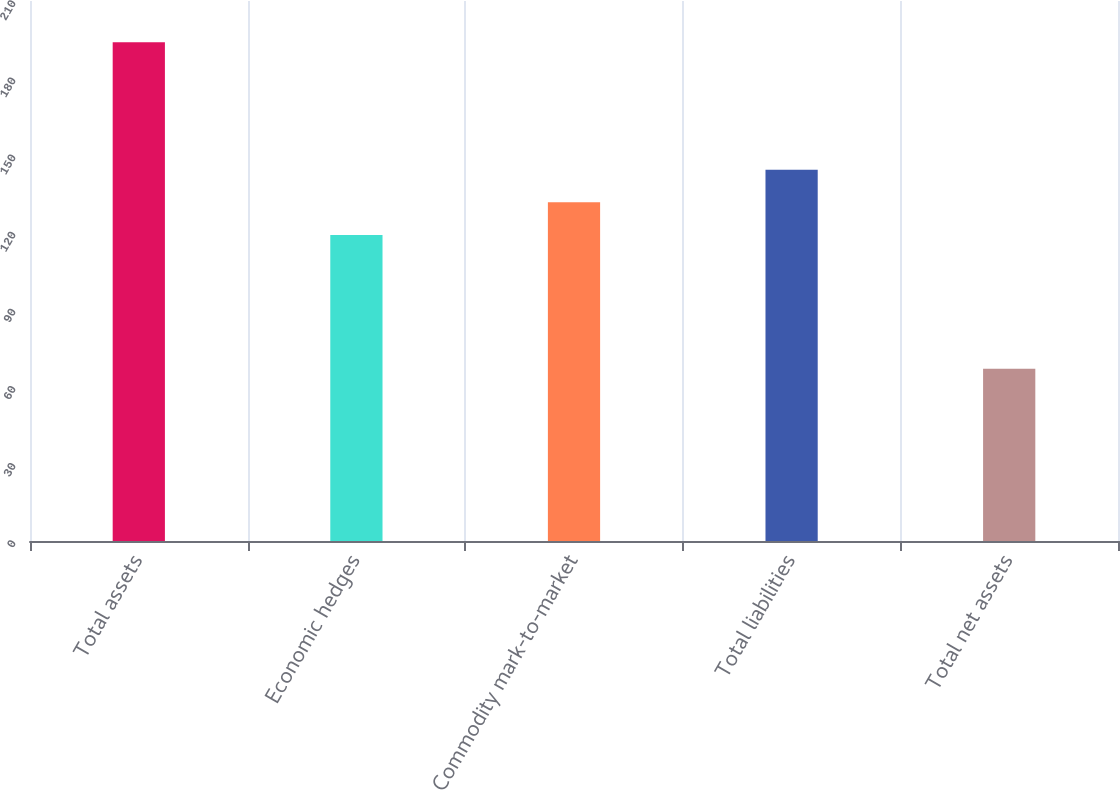<chart> <loc_0><loc_0><loc_500><loc_500><bar_chart><fcel>Total assets<fcel>Economic hedges<fcel>Commodity mark-to-market<fcel>Total liabilities<fcel>Total net assets<nl><fcel>194<fcel>119<fcel>131.7<fcel>144.4<fcel>67<nl></chart> 